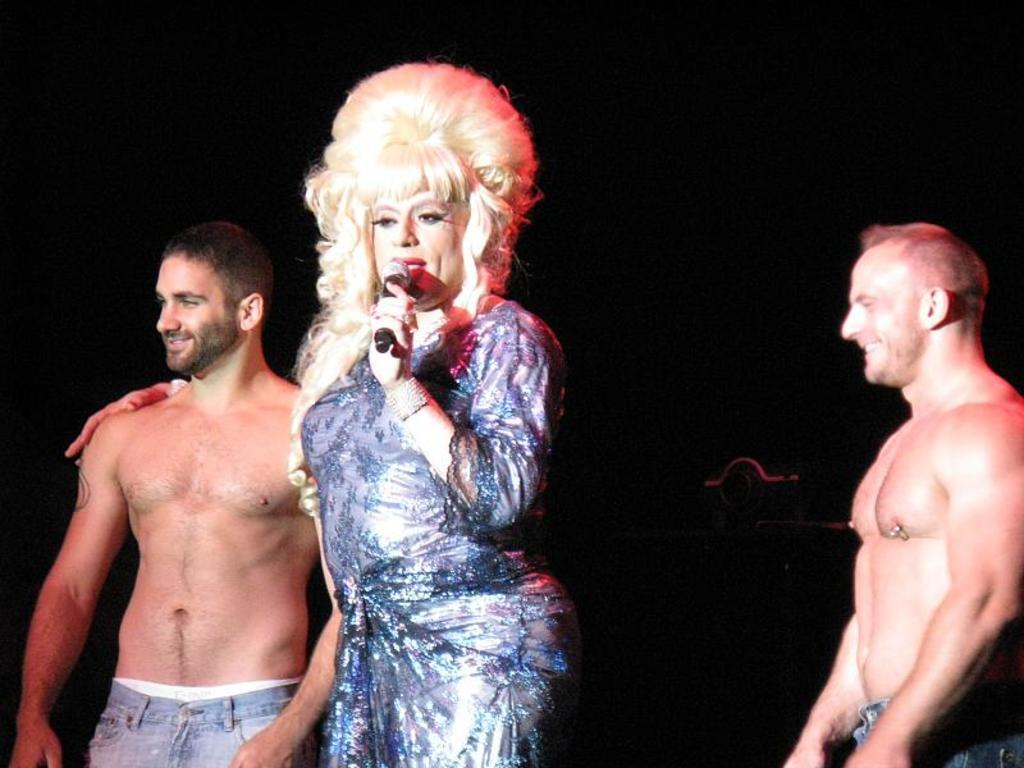How many people are in the image? There are three persons standing in the image. Can you describe the gender of one of the persons? One of the persons is a woman. What is the woman wearing in the image? The woman is wearing a dress. What object is the woman holding in her hand? The woman is holding a microphone in her hand. What type of parcel is being delivered to the woman in the image? There is no parcel being delivered to the woman in the image. What religious event is taking place in the image? There is no indication of a religious event in the image. 